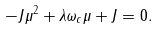Convert formula to latex. <formula><loc_0><loc_0><loc_500><loc_500>- J \mu ^ { 2 } + \lambda \omega _ { c } \mu + J = 0 .</formula> 